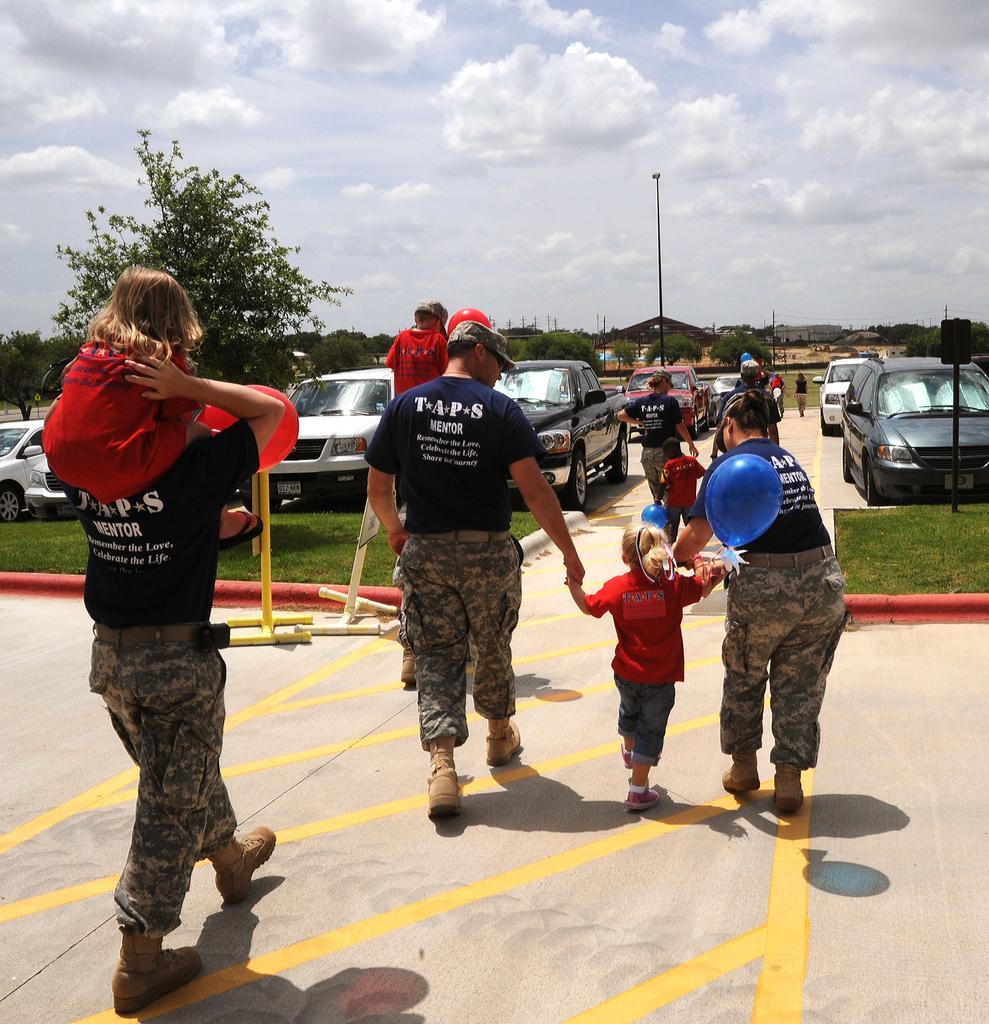Describe this image in one or two sentences. In this image we can see few people walking. Some are wearing caps. And some are holding balloons. On the ground there is grass. In the back there are vehicles. Also there are trees. In the background there is sky with clouds. 